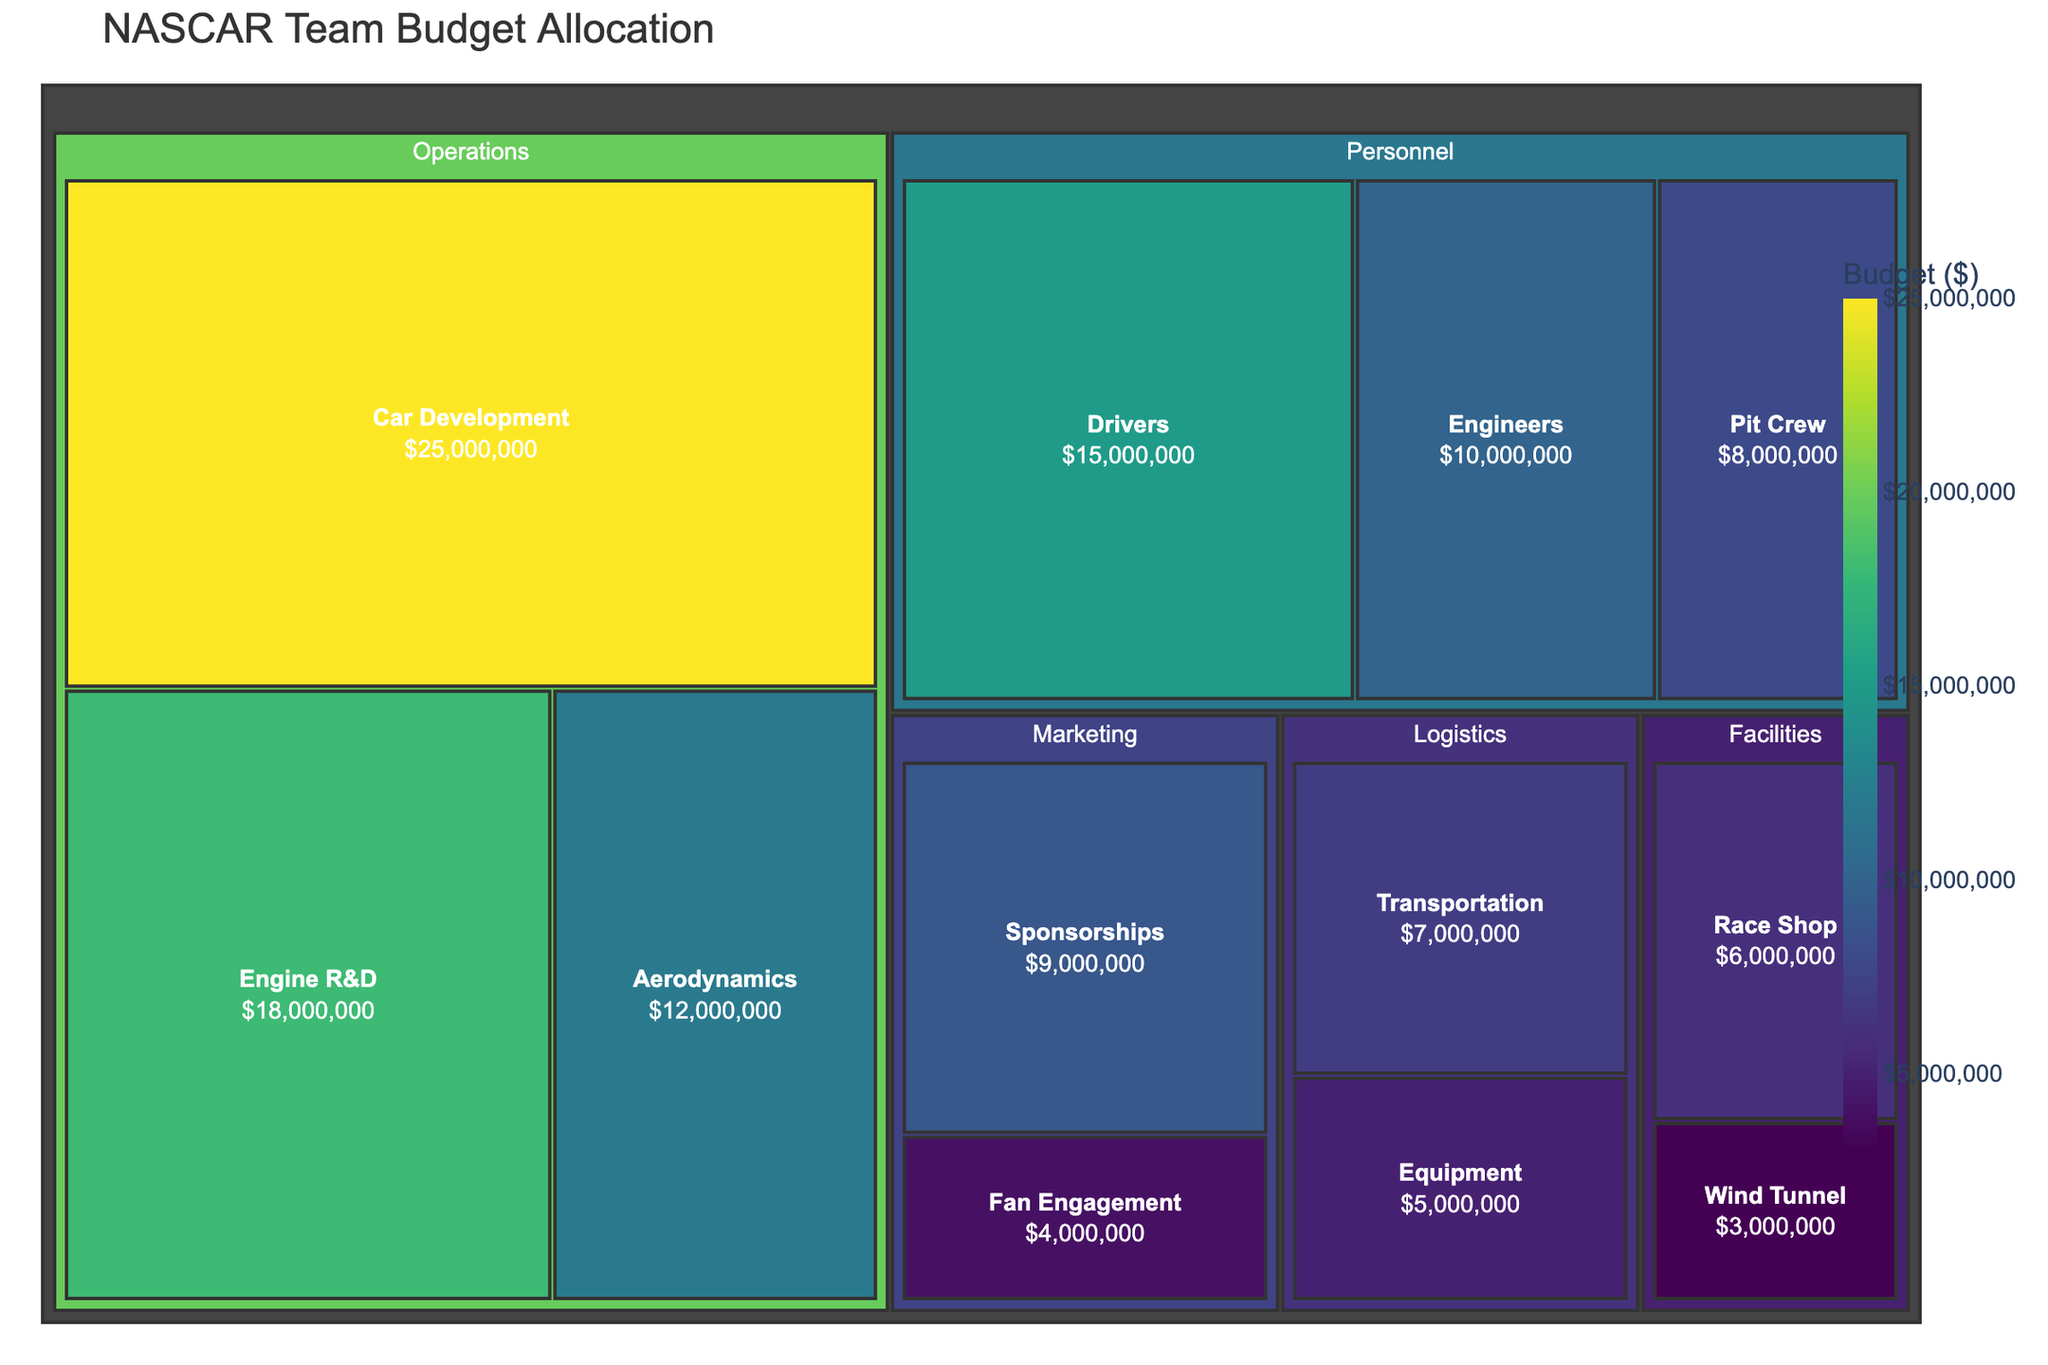What's the largest budget allocation category? The largest budget allocation category can be found by identifying the largest tile in the treemap. The "Operations" category has the largest tiles combining Car Development, Engine R&D, and Aerodynamics.
Answer: Operations Which subcategory within "Personnel" has the highest budget? Within the "Personnel" category, we look at the subcategories: Drivers, Pit Crew, and Engineers. The tile for Drivers is the largest.
Answer: Drivers What is the total budget for the "Marketing" category? Sum the budget values for subcategories under Marketing: Sponsorships ($9,000,000) and Fan Engagement ($4,000,000): $9,000,000 + $4,000,000 = $13,000,000.
Answer: $13,000,000 How does the budget for "Engine R&D" compare to "Car Development"? Compare the values for Engine R&D ($18,000,000) and Car Development ($25,000,000). Engine R&D has a smaller budget than Car Development.
Answer: Car Development has a higher budget What percent of the total budget is allocated to "Logistics"? First, calculate the total budget by summing all values: $25,000,000 (Car Development) + $18,000,000 (Engine R&D) + $12,000,000 (Aerodynamics) + $15,000,000 (Drivers) + $8,000,000 (Pit Crew) + $10,000,000 (Engineers) + $7,000,000 (Transportation) + $5,000,000 (Equipment) + $9,000,000 (Sponsorships) + $4,000,000 (Fan Engagement) + $6,000,000 (Race Shop) + $3,000,000 (Wind Tunnel) = $122,000,000. Then, sum the Logistics category: $7,000,000 (Transportation) + $5,000,000 (Equipment) = $12,000,000. The percentage is ($12,000,000 / $122,000,000) * 100 ≈ 9.84%.
Answer: 9.84% What is the combined budget for the "Facilities" category? Add the values for the subcategories under Facilities: $6,000,000 (Race Shop) + $3,000,000 (Wind Tunnel) = $9,000,000.
Answer: $9,000,000 Which subcategory in "Operations" has the lowest budget? Within Operations, compare Car Development, Engine R&D, and Aerodynamics. The smallest tile corresponds to Aerodynamics.
Answer: Aerodynamics Is the budget for "Sponsorships" larger than the budget for "Engineers"? Compare the budgets for Sponsorships ($9,000,000) and Engineers ($10,000,000). Sponsorships has a smaller budget compared to Engineers.
Answer: No What is the difference in budget between "Pit Crew" and "Engineers"? Subtract the Pit Crew budget from the Engineers budget: $10,000,000 (Engineers) - $8,000,000 (Pit Crew) = $2,000,000.
Answer: $2,000,000 